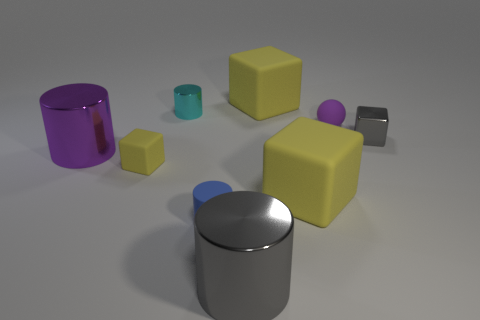Subtract all rubber cubes. How many cubes are left? 1 Add 1 gray things. How many objects exist? 10 Subtract 2 cylinders. How many cylinders are left? 2 Subtract all small gray blocks. Subtract all large yellow blocks. How many objects are left? 6 Add 5 tiny rubber blocks. How many tiny rubber blocks are left? 6 Add 6 small red spheres. How many small red spheres exist? 6 Subtract all gray cylinders. How many cylinders are left? 3 Subtract 0 red balls. How many objects are left? 9 Subtract all blocks. How many objects are left? 5 Subtract all purple cylinders. Subtract all gray cubes. How many cylinders are left? 3 